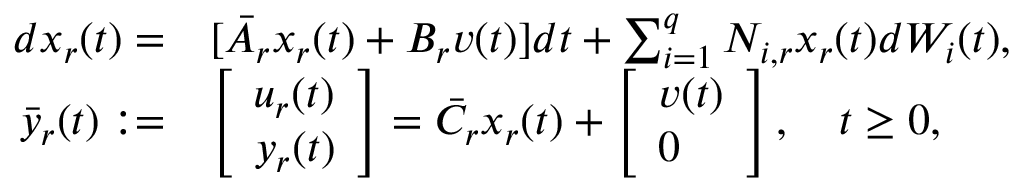Convert formula to latex. <formula><loc_0><loc_0><loc_500><loc_500>\begin{array} { r l } { d x _ { r } ( t ) = } & { [ \bar { A } _ { r } x _ { r } ( t ) + B _ { r } v ( t ) ] d t + \sum _ { i = 1 } ^ { q } N _ { i , r } x _ { r } ( t ) d W _ { i } ( t ) , } \\ { \bar { y } _ { r } ( t ) \colon = } & { \left [ \begin{array} { l } { u _ { r } ( t ) } \\ { y _ { r } ( t ) } \end{array} \right ] = \bar { C } _ { r } x _ { r } ( t ) + \left [ \begin{array} { l } { v ( t ) } \\ { 0 } \end{array} \right ] , \quad t \geq 0 , } \end{array}</formula> 